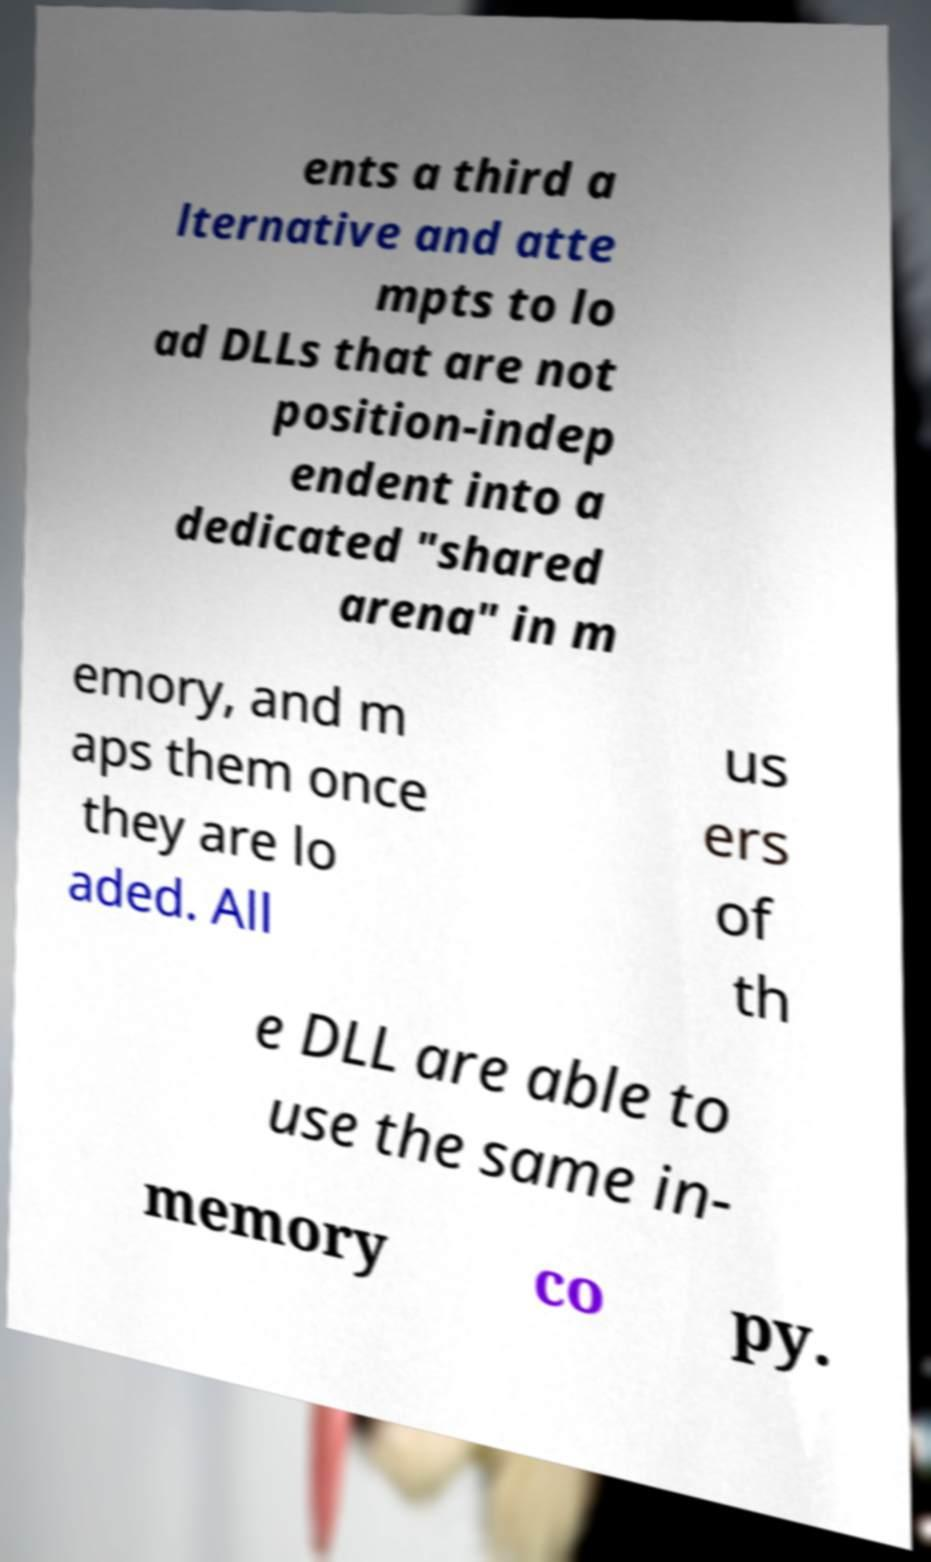For documentation purposes, I need the text within this image transcribed. Could you provide that? ents a third a lternative and atte mpts to lo ad DLLs that are not position-indep endent into a dedicated "shared arena" in m emory, and m aps them once they are lo aded. All us ers of th e DLL are able to use the same in- memory co py. 